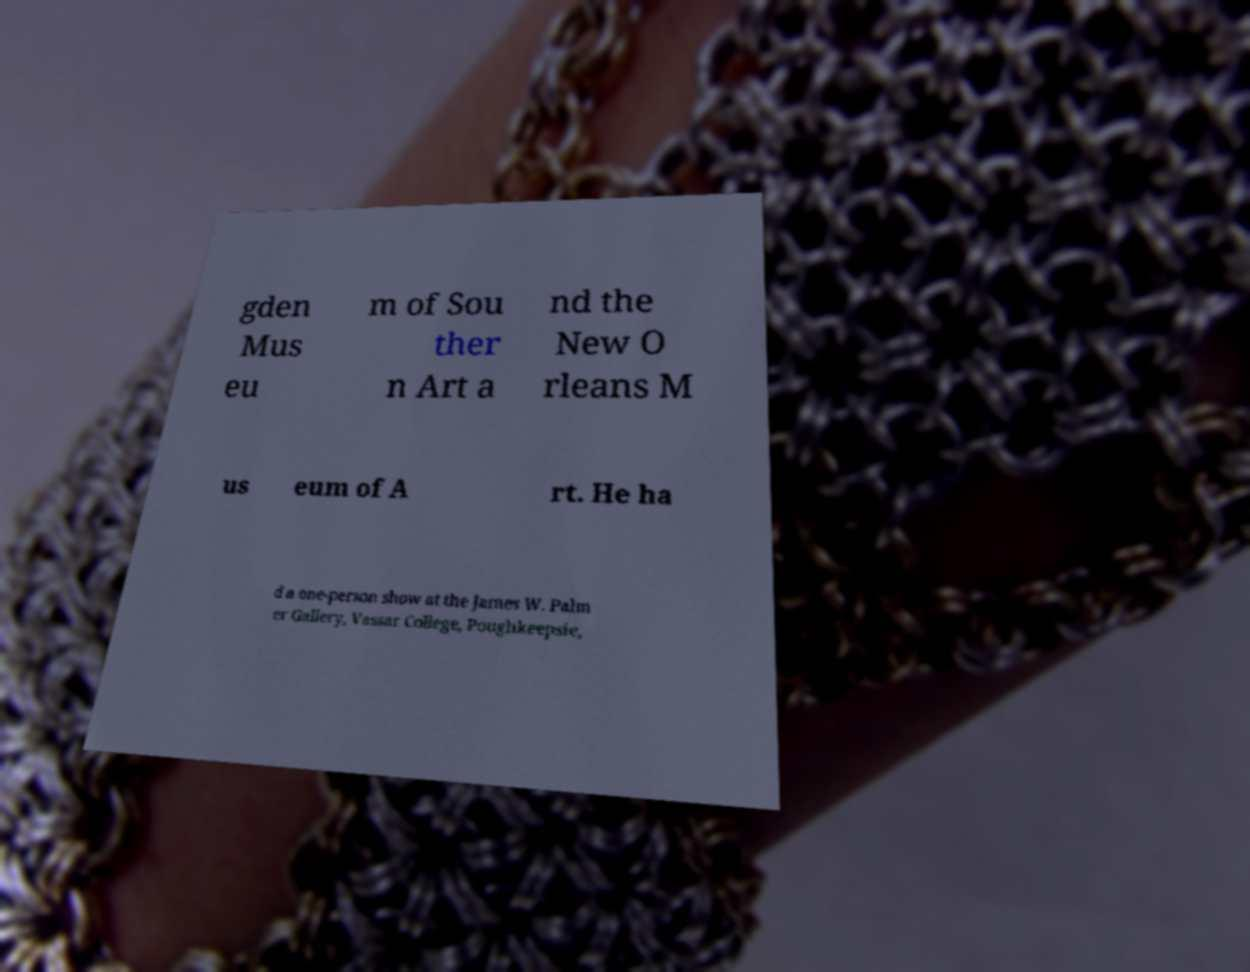What messages or text are displayed in this image? I need them in a readable, typed format. gden Mus eu m of Sou ther n Art a nd the New O rleans M us eum of A rt. He ha d a one-person show at the James W. Palm er Gallery, Vassar College, Poughkeepsie, 